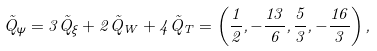Convert formula to latex. <formula><loc_0><loc_0><loc_500><loc_500>\vec { Q } _ { \psi } = 3 \vec { Q } _ { \xi } + 2 \vec { Q } _ { W } + 4 \vec { Q } _ { T } = \left ( \frac { 1 } { 2 } , - \frac { 1 3 } { 6 } , \frac { 5 } { 3 } , - \frac { 1 6 } { 3 } \right ) ,</formula> 